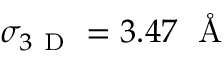Convert formula to latex. <formula><loc_0><loc_0><loc_500><loc_500>\sigma _ { 3 D } = 3 . 4 7 \, \AA</formula> 